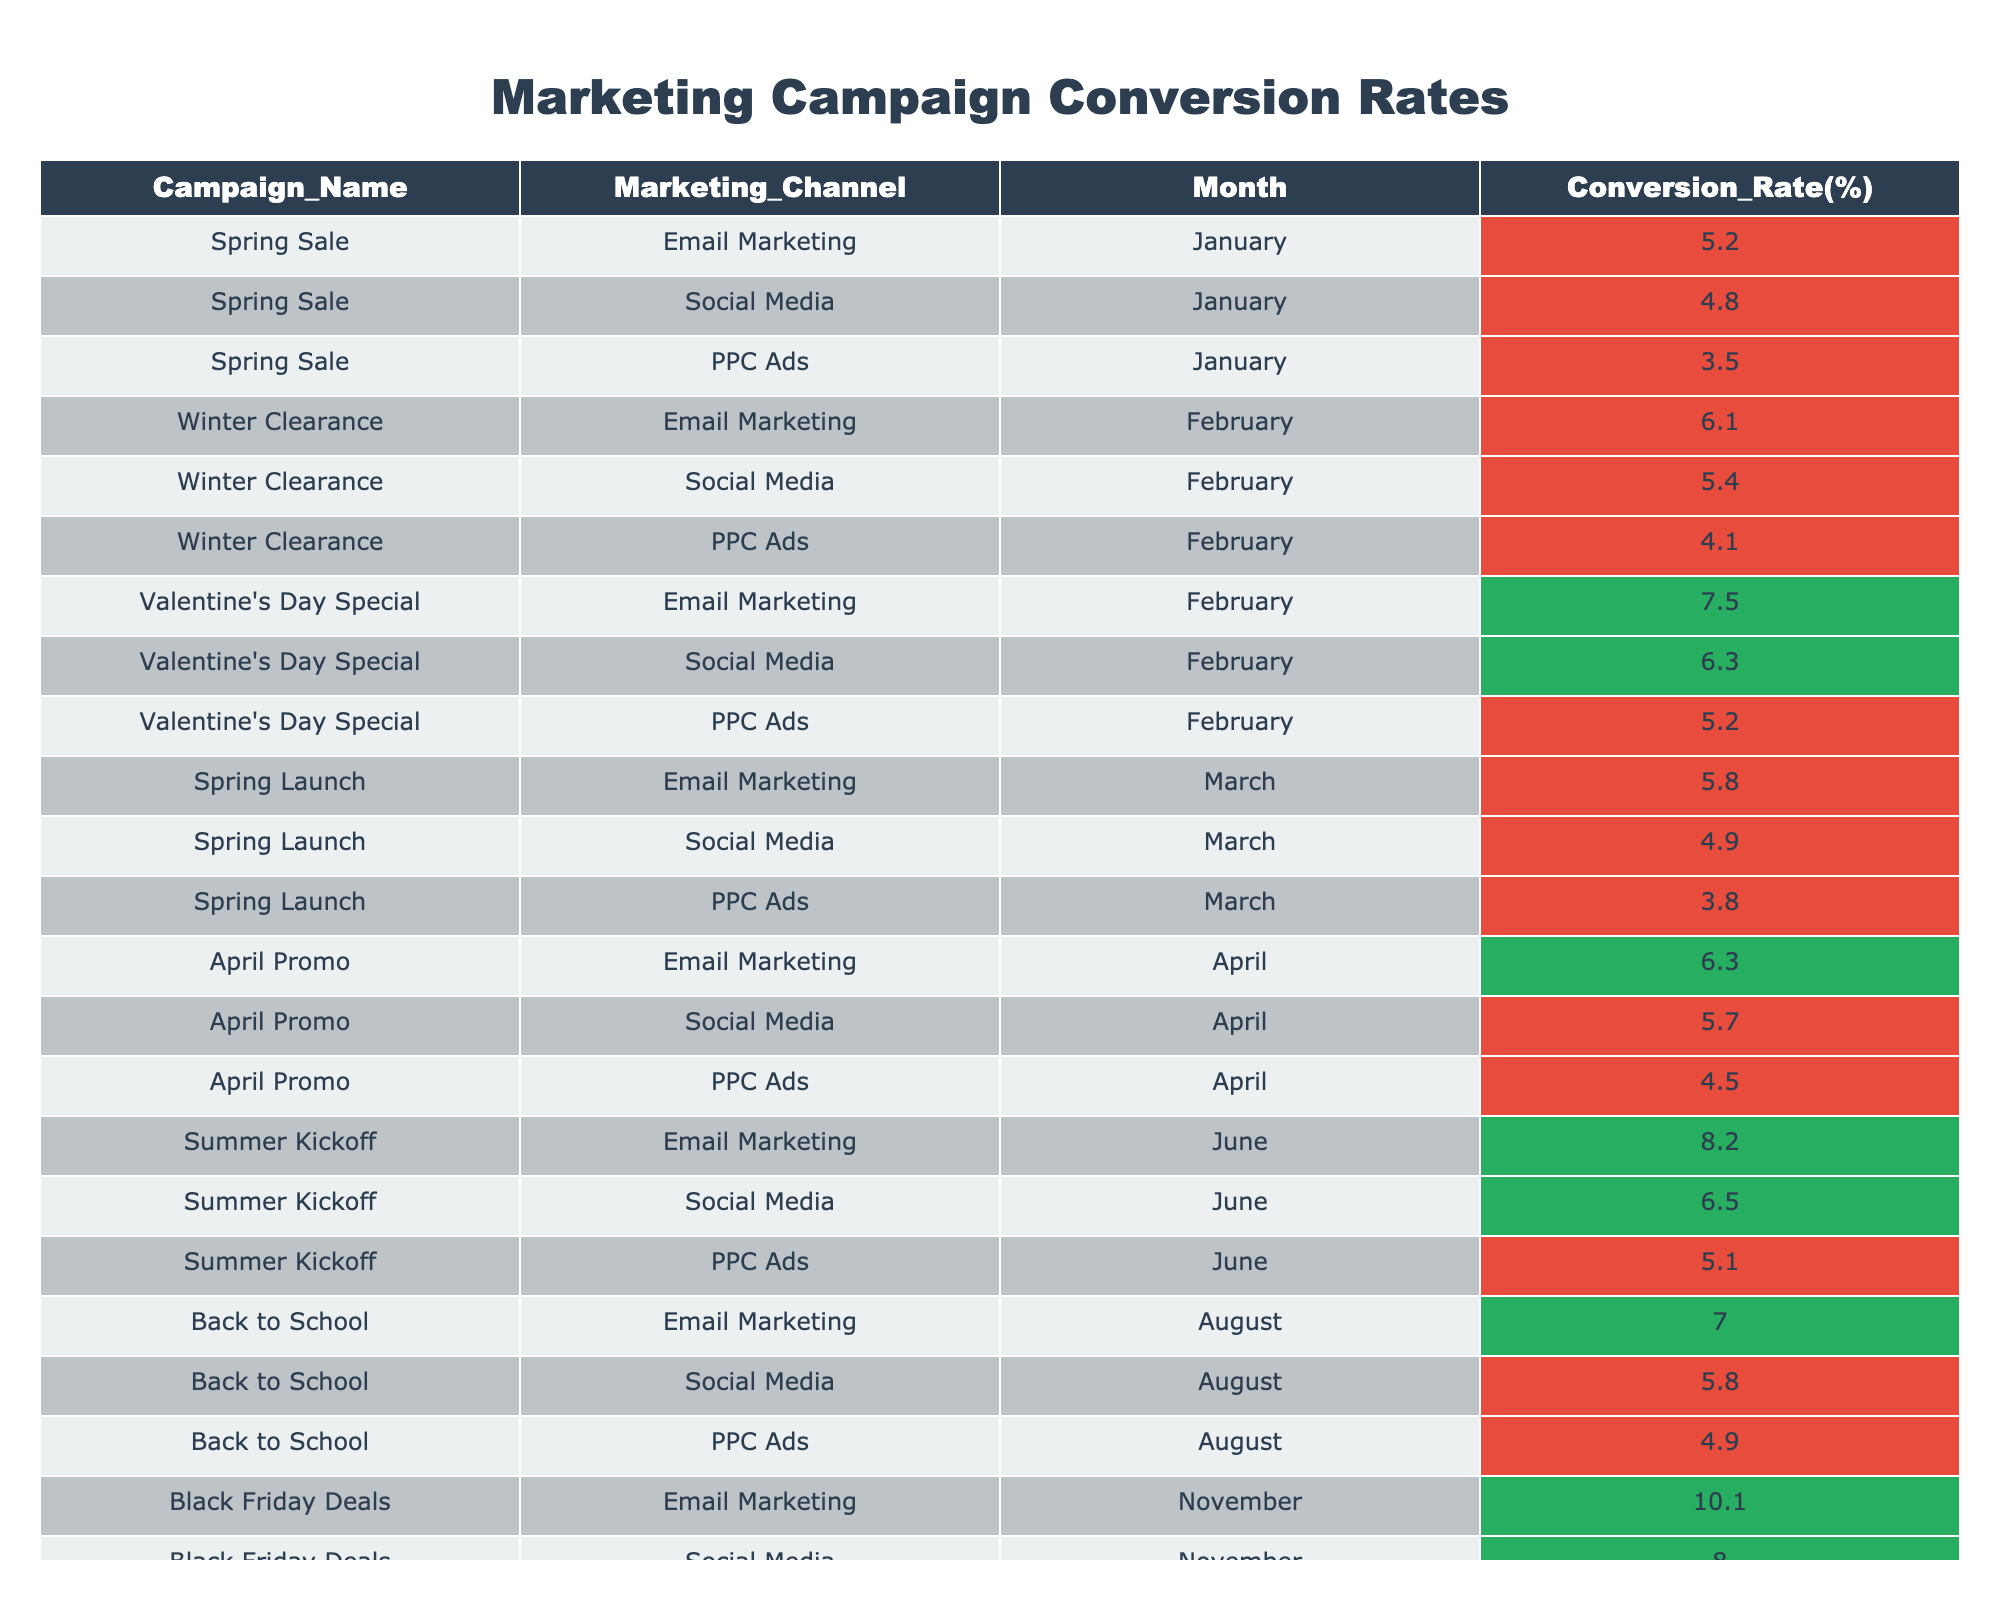What was the conversion rate for the "April Promo" campaign in Email Marketing? The table lists the conversion rates for various campaigns and their marketing channels. Looking under "April Promo" for the "Email Marketing" channel, the conversion rate is 6.3%.
Answer: 6.3% Which campaign in February had the highest conversion rate from PPC Ads? In February, I need to check the PPC Ads conversion rates for each campaign. "Valentine's Day Special" has a conversion rate of 5.2%, while "Winter Clearance" has 4.1%. So, the highest is 5.2%.
Answer: 5.2% What is the average conversion rate for Social Media campaigns across the year? To find the average, I add up all the Social Media conversion rates: (4.8 + 5.4 + 6.3 + 4.9 + 5.7 + 6.5 + 5.8 + 8.0 + 7.9) = 55.3%. There are 9 campaigns, so dividing gives 55.3 / 9 ≈ 6.14%.
Answer: 6.14% Did the "Back to School" campaign have a higher conversion rate for Email Marketing compared to Social Media? Looking at the table for "Back to School," the Email Marketing conversion rate is 7.0% and the Social Media rate is 5.8%. Since 7.0% is greater than 5.8%, the answer is yes.
Answer: Yes Which marketing channel had the lowest conversion rate in March, and what was the rate? Analyzing March's data, for "Spring Launch," the conversion rates are Email Marketing 5.8%, Social Media 4.9%, and PPC Ads 3.8%. The lowest is PPC Ads at 3.8%.
Answer: PPC Ads, 3.8% How does the conversion rate for the "Holiday Extravaganza" compare to the average conversion rate for all Email Marketing campaigns? First, the "Holiday Extravaganza" Email Marketing rate is 9.3%. The Email Marketing rates for other months are: 5.2, 6.1, 7.5, 5.8, 6.3, 8.2, 7.0, and 10.1. Adding these gives a total of 56.2%. There are 8 campaigns, so the average is 56.2 / 8 = 7.025%. The "Holiday Extravaganza" at 9.3% is higher than the average of 7.025%.
Answer: Yes What are the maximum and minimum conversion rates for PPC Ads across the entire year? By reviewing the data, the PPC Ads conversion rates are: 3.5% (January), 4.1% (February), 5.2% (February), 3.8% (March), 4.5% (April), 5.1% (June), 4.9% (August), 7.4% (November), and 6.6% (December). The maximum is 7.4% and the minimum is 3.5%.
Answer: Max: 7.4%, Min: 3.5% In which month did the "Black Friday Deals" Email Marketing campaign achieve the highest conversion rate, and what was it? The "Black Friday Deals" campaign's conversion rate for Email Marketing is 10.1% in November, which is the highest among all Email Marketing campaigns in any month throughout the year.
Answer: November, 10.1% 